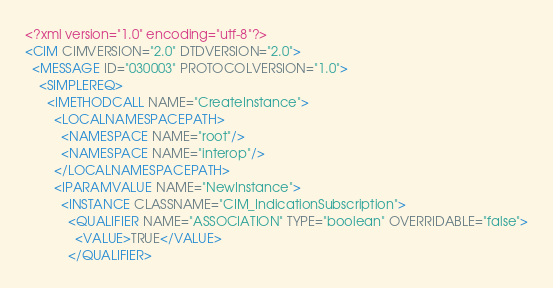Convert code to text. <code><loc_0><loc_0><loc_500><loc_500><_XML_><?xml version="1.0" encoding="utf-8"?>
<CIM CIMVERSION="2.0" DTDVERSION="2.0">
  <MESSAGE ID="030003" PROTOCOLVERSION="1.0">
    <SIMPLEREQ>
      <IMETHODCALL NAME="CreateInstance">
        <LOCALNAMESPACEPATH>
          <NAMESPACE NAME="root"/>
          <NAMESPACE NAME="interop"/>
        </LOCALNAMESPACEPATH>
        <IPARAMVALUE NAME="NewInstance">
          <INSTANCE CLASSNAME="CIM_IndicationSubscription">
            <QUALIFIER NAME="ASSOCIATION" TYPE="boolean" OVERRIDABLE="false">
              <VALUE>TRUE</VALUE>
            </QUALIFIER></code> 